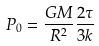<formula> <loc_0><loc_0><loc_500><loc_500>P _ { 0 } = \frac { G M } { R ^ { 2 } } \frac { 2 \tau } { 3 k }</formula> 